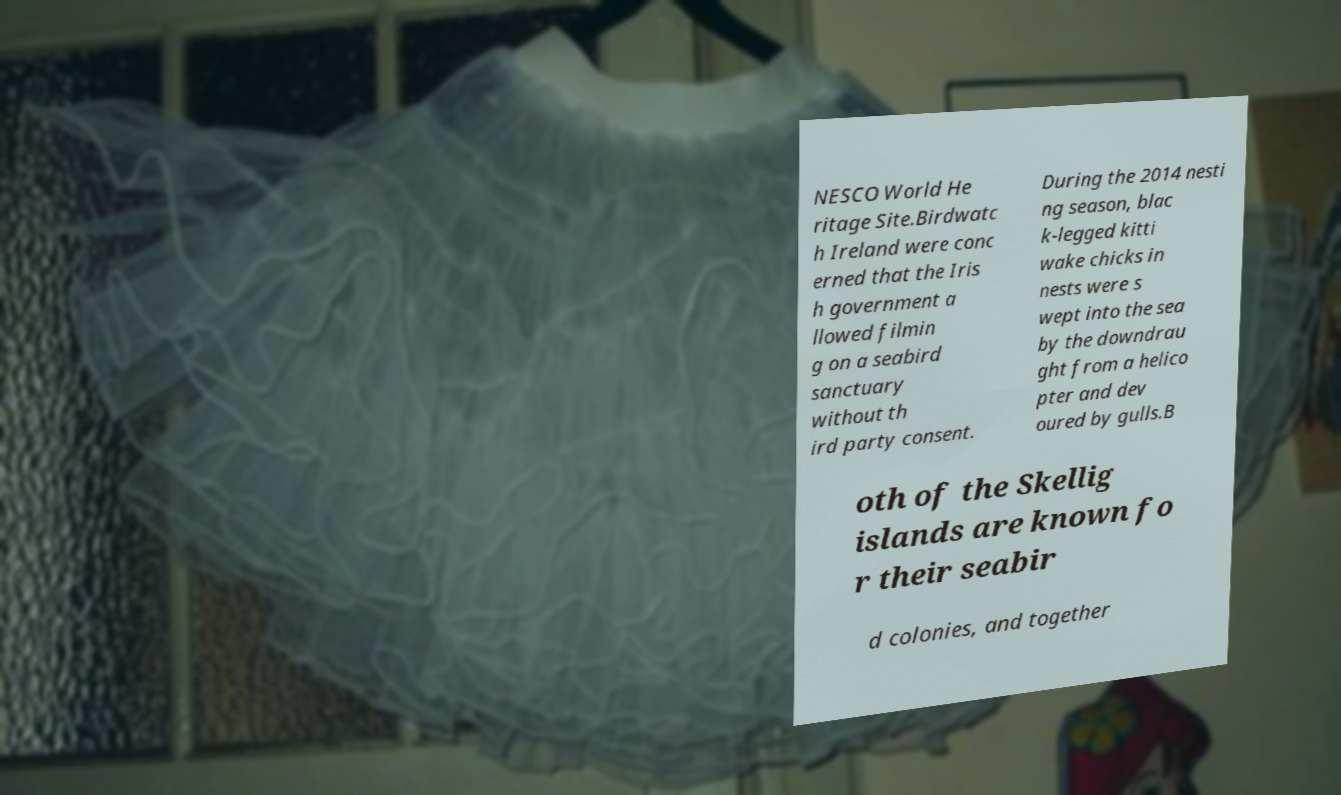There's text embedded in this image that I need extracted. Can you transcribe it verbatim? NESCO World He ritage Site.Birdwatc h Ireland were conc erned that the Iris h government a llowed filmin g on a seabird sanctuary without th ird party consent. During the 2014 nesti ng season, blac k-legged kitti wake chicks in nests were s wept into the sea by the downdrau ght from a helico pter and dev oured by gulls.B oth of the Skellig islands are known fo r their seabir d colonies, and together 